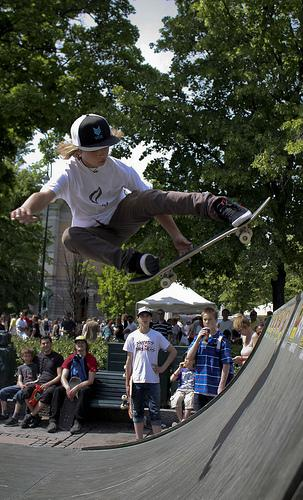Question: where is the skateboard?
Choices:
A. In the air.
B. On the ground.
C. On the cement.
D. On the grass.
Answer with the letter. Answer: A Question: what is white?
Choices:
A. Shirt.
B. Socks.
C. Shoes.
D. Coat.
Answer with the letter. Answer: A Question: what is grey?
Choices:
A. Sidewalk.
B. Road.
C. Stairs.
D. Ramp.
Answer with the letter. Answer: D Question: why is he in the air?
Choices:
A. Falling.
B. Skiing.
C. Jumping.
D. Snowboarding.
Answer with the letter. Answer: C 